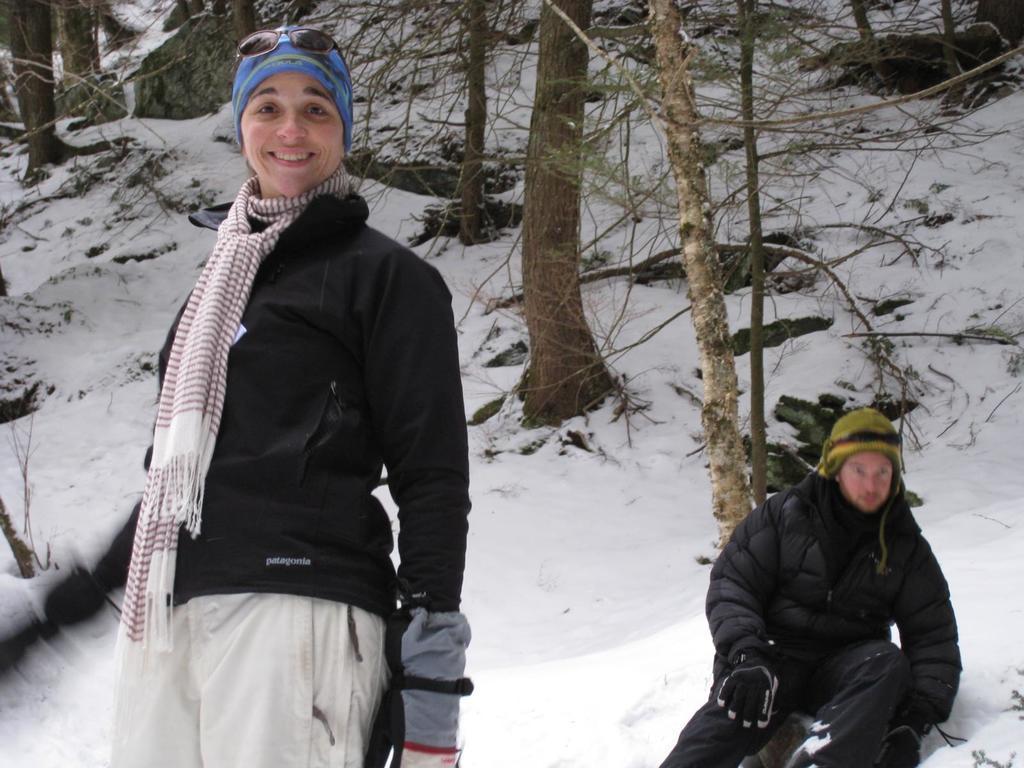How would you summarize this image in a sentence or two? This image consists of ice. There are trees in the middle and top. There are two persons in the middle. They are wearing sweaters, caps, gloves. 